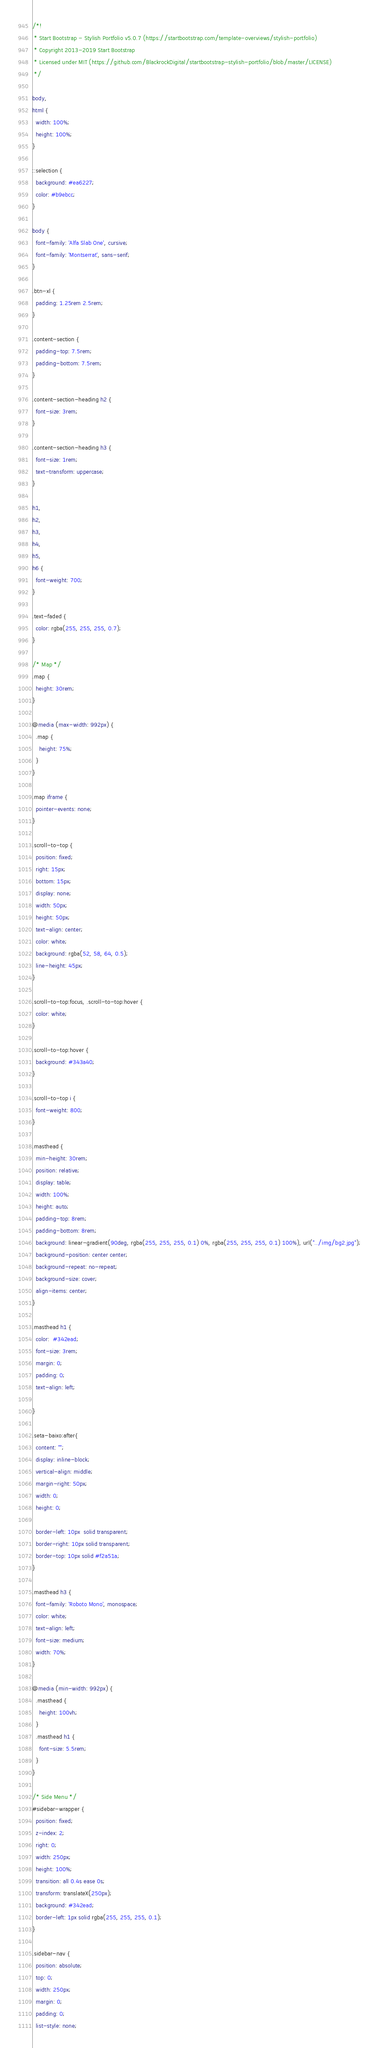Convert code to text. <code><loc_0><loc_0><loc_500><loc_500><_CSS_>/*!
 * Start Bootstrap - Stylish Portfolio v5.0.7 (https://startbootstrap.com/template-overviews/stylish-portfolio)
 * Copyright 2013-2019 Start Bootstrap
 * Licensed under MIT (https://github.com/BlackrockDigital/startbootstrap-stylish-portfolio/blob/master/LICENSE)
 */

body,
html {
  width: 100%;
  height: 100%;
}

::selection {
  background: #ea6227;
  color: #b9ebcc;
}

body {
  font-family: 'Alfa Slab One', cursive;
  font-family: 'Montserrat', sans-serif;
}

.btn-xl {
  padding: 1.25rem 2.5rem;
}

.content-section {
  padding-top: 7.5rem;
  padding-bottom: 7.5rem;
}

.content-section-heading h2 {
  font-size: 3rem;
}

.content-section-heading h3 {
  font-size: 1rem;
  text-transform: uppercase;
}

h1,
h2,
h3,
h4,
h5,
h6 {
  font-weight: 700;
}

.text-faded {
  color: rgba(255, 255, 255, 0.7);
}

/* Map */
.map {
  height: 30rem;
}

@media (max-width: 992px) {
  .map {
    height: 75%;
  }
}

.map iframe {
  pointer-events: none;
}

.scroll-to-top {
  position: fixed;
  right: 15px;
  bottom: 15px;
  display: none;
  width: 50px;
  height: 50px;
  text-align: center;
  color: white;
  background: rgba(52, 58, 64, 0.5);
  line-height: 45px;
}

.scroll-to-top:focus, .scroll-to-top:hover {
  color: white;
}

.scroll-to-top:hover {
  background: #343a40;
}

.scroll-to-top i {
  font-weight: 800;
}

.masthead {
  min-height: 30rem;
  position: relative;
  display: table;
  width: 100%;
  height: auto;
  padding-top: 8rem;
  padding-bottom: 8rem;
  background: linear-gradient(90deg, rgba(255, 255, 255, 0.1) 0%, rgba(255, 255, 255, 0.1) 100%), url("../img/bg2.jpg");
  background-position: center center;
  background-repeat: no-repeat;
  background-size: cover;
  align-items: center;
}

.masthead h1 {
  color:  #342ead;
  font-size: 3rem;
  margin: 0;
  padding: 0;
  text-align: left;

}

.seta-baixo:after{
  content: "";
  display: inline-block;
  vertical-align: middle;
  margin-right: 50px;
  width: 0;
  height: 0;

  border-left: 10px  solid transparent;
  border-right: 10px solid transparent;
  border-top: 10px solid #f2a51a;
}

.masthead h3 {
  font-family: 'Roboto Mono', monospace;
  color: white;
  text-align: left;
  font-size: medium;
  width: 70%;
}

@media (min-width: 992px) {
  .masthead {
    height: 100vh;
  }
  .masthead h1 {
    font-size: 5.5rem;
  }
}

/* Side Menu */
#sidebar-wrapper {
  position: fixed;
  z-index: 2;
  right: 0;
  width: 250px;
  height: 100%;
  transition: all 0.4s ease 0s;
  transform: translateX(250px);
  background: #342ead;
  border-left: 1px solid rgba(255, 255, 255, 0.1);
}

.sidebar-nav {
  position: absolute;
  top: 0;
  width: 250px;
  margin: 0;
  padding: 0;
  list-style: none;</code> 